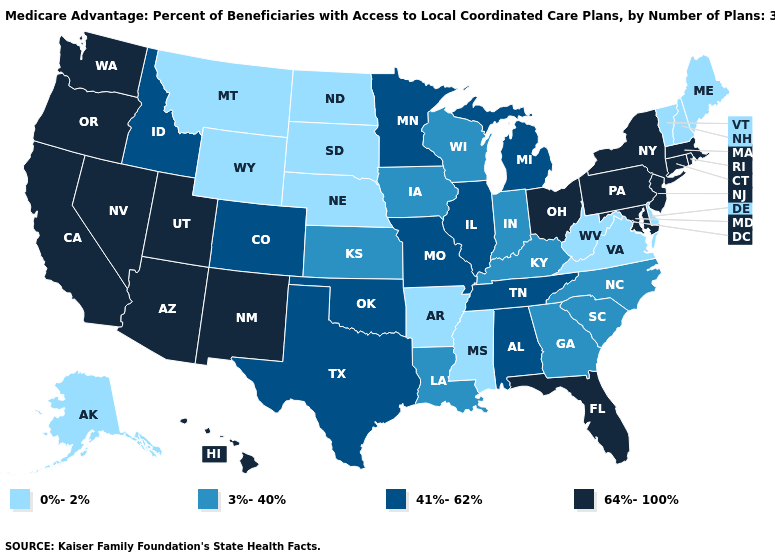Does Iowa have the lowest value in the MidWest?
Short answer required. No. Does the first symbol in the legend represent the smallest category?
Be succinct. Yes. Name the states that have a value in the range 41%-62%?
Quick response, please. Alabama, Colorado, Idaho, Illinois, Michigan, Minnesota, Missouri, Oklahoma, Tennessee, Texas. Name the states that have a value in the range 41%-62%?
Give a very brief answer. Alabama, Colorado, Idaho, Illinois, Michigan, Minnesota, Missouri, Oklahoma, Tennessee, Texas. Name the states that have a value in the range 3%-40%?
Give a very brief answer. Georgia, Iowa, Indiana, Kansas, Kentucky, Louisiana, North Carolina, South Carolina, Wisconsin. Does Colorado have the highest value in the West?
Write a very short answer. No. What is the value of New York?
Be succinct. 64%-100%. Does Utah have the same value as Wisconsin?
Concise answer only. No. Which states hav the highest value in the Northeast?
Quick response, please. Connecticut, Massachusetts, New Jersey, New York, Pennsylvania, Rhode Island. What is the highest value in states that border Texas?
Quick response, please. 64%-100%. What is the value of Alaska?
Be succinct. 0%-2%. Among the states that border California , which have the highest value?
Concise answer only. Arizona, Nevada, Oregon. Does North Carolina have a lower value than New York?
Be succinct. Yes. Does Maryland have the same value as Georgia?
Concise answer only. No. 